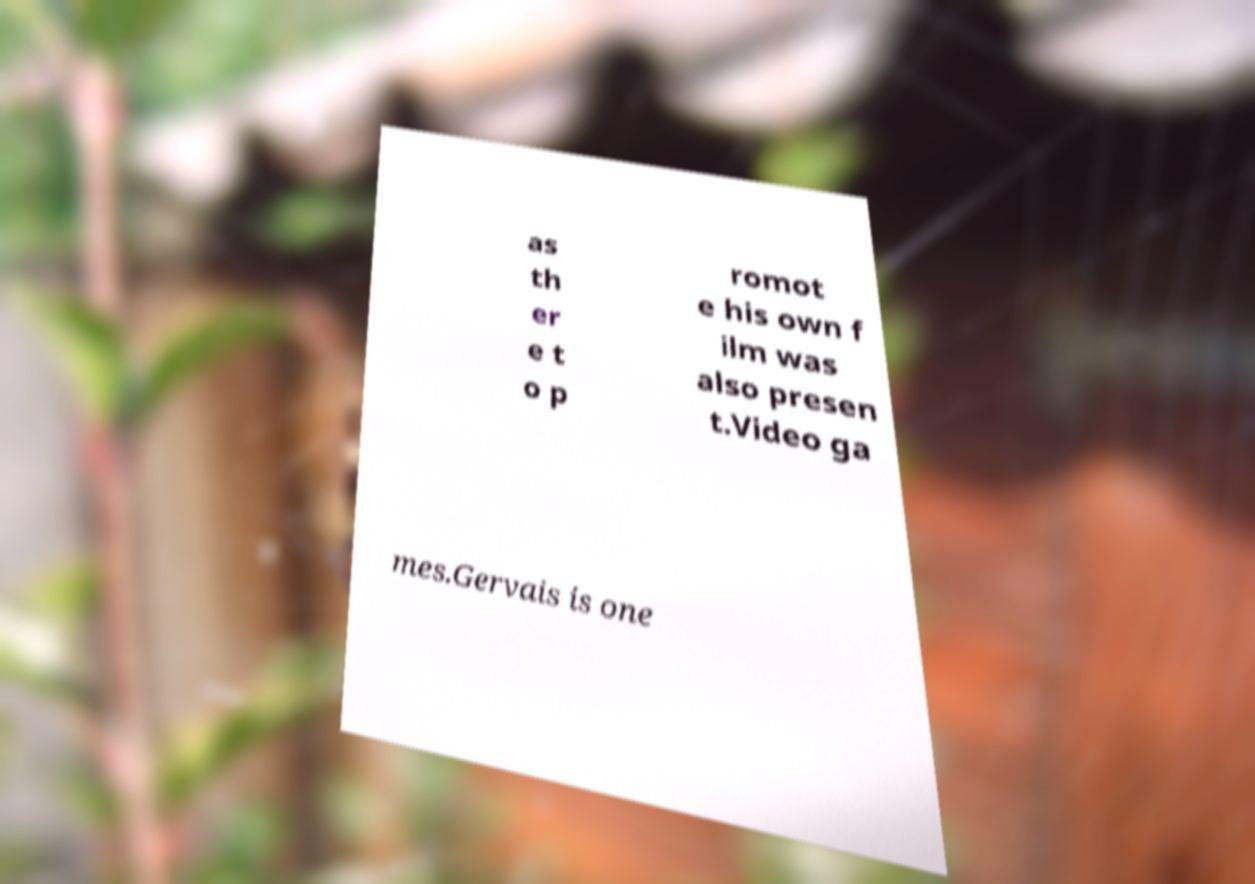For documentation purposes, I need the text within this image transcribed. Could you provide that? as th er e t o p romot e his own f ilm was also presen t.Video ga mes.Gervais is one 